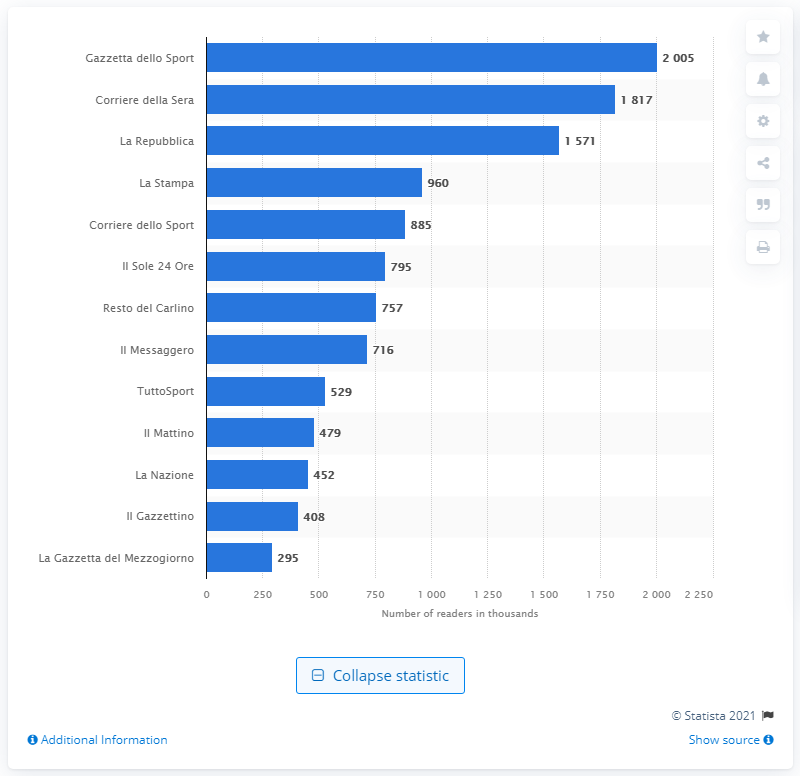Draw attention to some important aspects in this diagram. Based on readership data between February 2020 and January 2021, La Repubblica was the third most read newspaper in Italy. Gazzetta dello Sport was the most read newspaper in Italy between February 2020 and January 2021, according to recent statistics. 